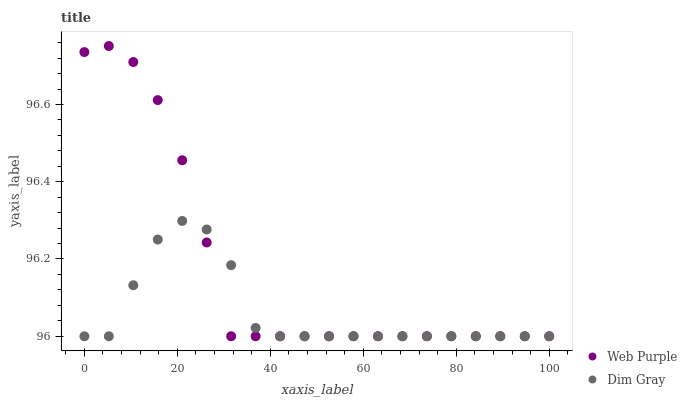Does Dim Gray have the minimum area under the curve?
Answer yes or no. Yes. Does Web Purple have the maximum area under the curve?
Answer yes or no. Yes. Does Dim Gray have the maximum area under the curve?
Answer yes or no. No. Is Web Purple the smoothest?
Answer yes or no. Yes. Is Dim Gray the roughest?
Answer yes or no. Yes. Is Dim Gray the smoothest?
Answer yes or no. No. Does Web Purple have the lowest value?
Answer yes or no. Yes. Does Web Purple have the highest value?
Answer yes or no. Yes. Does Dim Gray have the highest value?
Answer yes or no. No. Does Dim Gray intersect Web Purple?
Answer yes or no. Yes. Is Dim Gray less than Web Purple?
Answer yes or no. No. Is Dim Gray greater than Web Purple?
Answer yes or no. No. 